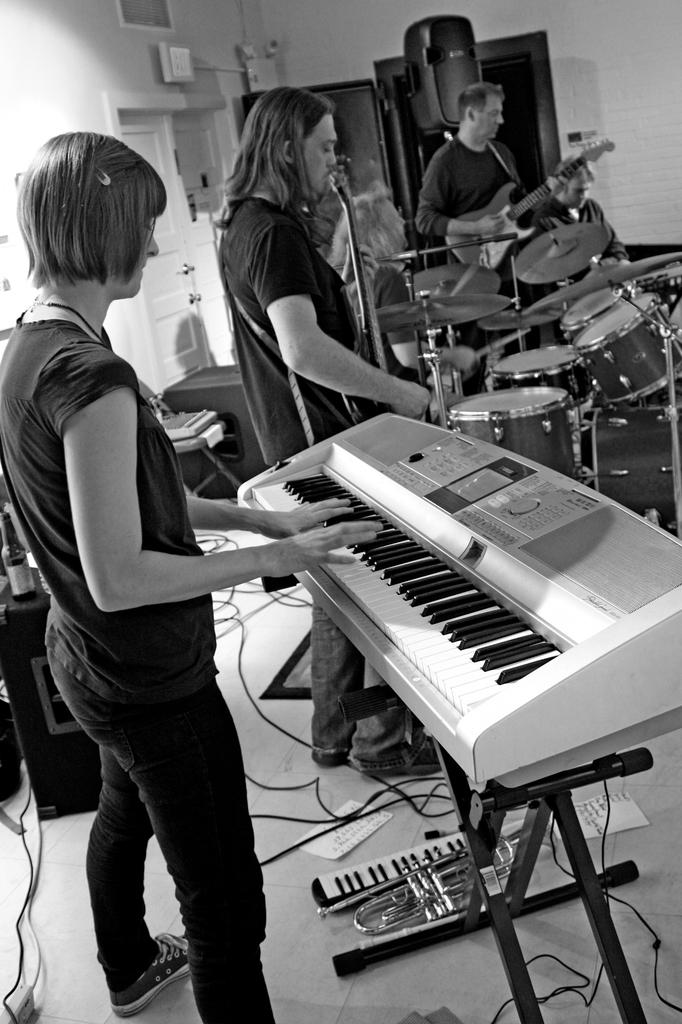What is the color scheme of the image? The image is black and white. How many people are in the image? There are three persons in the image. What are the persons doing in the image? The persons are playing musical instruments. Where is the scene taking place? The scene is on the floor. What can be seen in the background of the image? There is a door and a wall visible in the background. How do the persons in the image control their eyes while playing their instruments? There is no mention of eye control in the image, as the focus is on the persons playing musical instruments. 